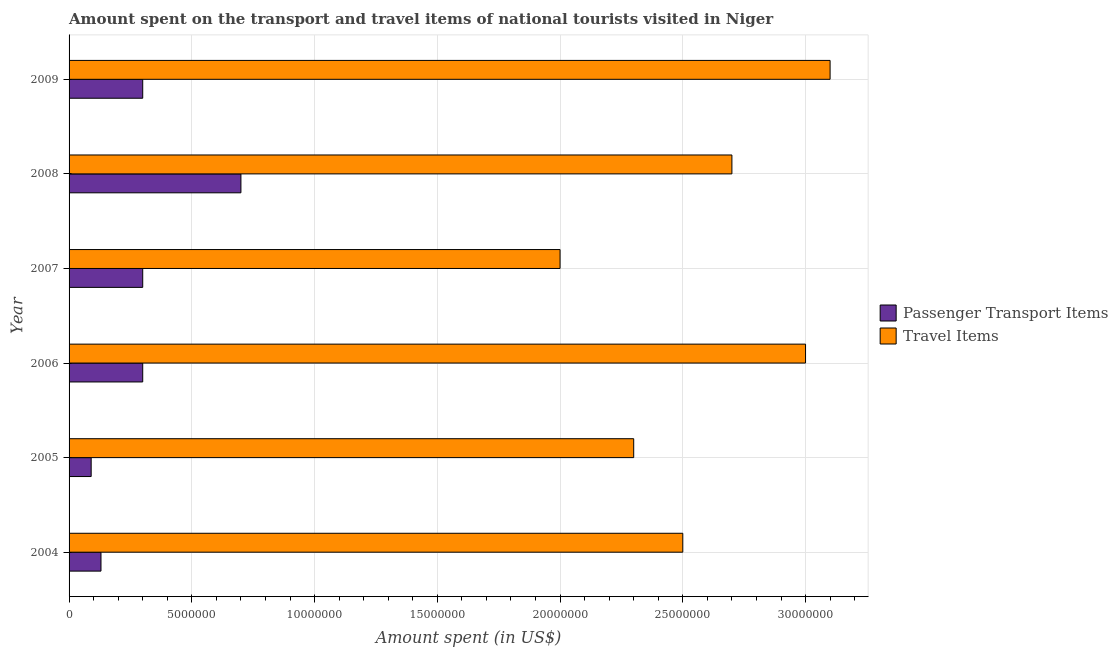How many different coloured bars are there?
Your answer should be compact. 2. How many groups of bars are there?
Provide a succinct answer. 6. Are the number of bars per tick equal to the number of legend labels?
Provide a short and direct response. Yes. What is the amount spent on passenger transport items in 2004?
Provide a succinct answer. 1.30e+06. Across all years, what is the maximum amount spent in travel items?
Make the answer very short. 3.10e+07. Across all years, what is the minimum amount spent in travel items?
Give a very brief answer. 2.00e+07. In which year was the amount spent on passenger transport items minimum?
Provide a succinct answer. 2005. What is the total amount spent in travel items in the graph?
Offer a very short reply. 1.56e+08. What is the difference between the amount spent on passenger transport items in 2004 and that in 2008?
Provide a succinct answer. -5.70e+06. What is the difference between the amount spent on passenger transport items in 2004 and the amount spent in travel items in 2006?
Give a very brief answer. -2.87e+07. What is the average amount spent on passenger transport items per year?
Provide a succinct answer. 3.03e+06. In the year 2006, what is the difference between the amount spent on passenger transport items and amount spent in travel items?
Your response must be concise. -2.70e+07. In how many years, is the amount spent on passenger transport items greater than 17000000 US$?
Offer a terse response. 0. What is the difference between the highest and the lowest amount spent in travel items?
Keep it short and to the point. 1.10e+07. What does the 1st bar from the top in 2004 represents?
Give a very brief answer. Travel Items. What does the 2nd bar from the bottom in 2006 represents?
Your response must be concise. Travel Items. How many bars are there?
Offer a very short reply. 12. What is the difference between two consecutive major ticks on the X-axis?
Give a very brief answer. 5.00e+06. Does the graph contain any zero values?
Make the answer very short. No. How many legend labels are there?
Your answer should be compact. 2. How are the legend labels stacked?
Your answer should be very brief. Vertical. What is the title of the graph?
Provide a short and direct response. Amount spent on the transport and travel items of national tourists visited in Niger. Does "% of gross capital formation" appear as one of the legend labels in the graph?
Keep it short and to the point. No. What is the label or title of the X-axis?
Ensure brevity in your answer.  Amount spent (in US$). What is the Amount spent (in US$) in Passenger Transport Items in 2004?
Provide a succinct answer. 1.30e+06. What is the Amount spent (in US$) of Travel Items in 2004?
Provide a short and direct response. 2.50e+07. What is the Amount spent (in US$) in Travel Items in 2005?
Keep it short and to the point. 2.30e+07. What is the Amount spent (in US$) of Travel Items in 2006?
Provide a short and direct response. 3.00e+07. What is the Amount spent (in US$) in Passenger Transport Items in 2007?
Make the answer very short. 3.00e+06. What is the Amount spent (in US$) in Travel Items in 2008?
Provide a short and direct response. 2.70e+07. What is the Amount spent (in US$) in Travel Items in 2009?
Give a very brief answer. 3.10e+07. Across all years, what is the maximum Amount spent (in US$) of Travel Items?
Provide a short and direct response. 3.10e+07. Across all years, what is the minimum Amount spent (in US$) of Passenger Transport Items?
Your response must be concise. 9.00e+05. What is the total Amount spent (in US$) in Passenger Transport Items in the graph?
Offer a terse response. 1.82e+07. What is the total Amount spent (in US$) in Travel Items in the graph?
Give a very brief answer. 1.56e+08. What is the difference between the Amount spent (in US$) in Passenger Transport Items in 2004 and that in 2005?
Provide a succinct answer. 4.00e+05. What is the difference between the Amount spent (in US$) in Passenger Transport Items in 2004 and that in 2006?
Give a very brief answer. -1.70e+06. What is the difference between the Amount spent (in US$) of Travel Items in 2004 and that in 2006?
Keep it short and to the point. -5.00e+06. What is the difference between the Amount spent (in US$) of Passenger Transport Items in 2004 and that in 2007?
Keep it short and to the point. -1.70e+06. What is the difference between the Amount spent (in US$) of Travel Items in 2004 and that in 2007?
Provide a succinct answer. 5.00e+06. What is the difference between the Amount spent (in US$) in Passenger Transport Items in 2004 and that in 2008?
Offer a terse response. -5.70e+06. What is the difference between the Amount spent (in US$) in Passenger Transport Items in 2004 and that in 2009?
Provide a succinct answer. -1.70e+06. What is the difference between the Amount spent (in US$) in Travel Items in 2004 and that in 2009?
Keep it short and to the point. -6.00e+06. What is the difference between the Amount spent (in US$) in Passenger Transport Items in 2005 and that in 2006?
Your response must be concise. -2.10e+06. What is the difference between the Amount spent (in US$) in Travel Items in 2005 and that in 2006?
Your response must be concise. -7.00e+06. What is the difference between the Amount spent (in US$) of Passenger Transport Items in 2005 and that in 2007?
Give a very brief answer. -2.10e+06. What is the difference between the Amount spent (in US$) of Passenger Transport Items in 2005 and that in 2008?
Give a very brief answer. -6.10e+06. What is the difference between the Amount spent (in US$) in Passenger Transport Items in 2005 and that in 2009?
Keep it short and to the point. -2.10e+06. What is the difference between the Amount spent (in US$) in Travel Items in 2005 and that in 2009?
Provide a short and direct response. -8.00e+06. What is the difference between the Amount spent (in US$) in Passenger Transport Items in 2006 and that in 2007?
Offer a very short reply. 0. What is the difference between the Amount spent (in US$) in Passenger Transport Items in 2006 and that in 2009?
Your response must be concise. 0. What is the difference between the Amount spent (in US$) in Travel Items in 2007 and that in 2008?
Provide a short and direct response. -7.00e+06. What is the difference between the Amount spent (in US$) in Travel Items in 2007 and that in 2009?
Provide a succinct answer. -1.10e+07. What is the difference between the Amount spent (in US$) of Travel Items in 2008 and that in 2009?
Your answer should be compact. -4.00e+06. What is the difference between the Amount spent (in US$) in Passenger Transport Items in 2004 and the Amount spent (in US$) in Travel Items in 2005?
Give a very brief answer. -2.17e+07. What is the difference between the Amount spent (in US$) of Passenger Transport Items in 2004 and the Amount spent (in US$) of Travel Items in 2006?
Make the answer very short. -2.87e+07. What is the difference between the Amount spent (in US$) in Passenger Transport Items in 2004 and the Amount spent (in US$) in Travel Items in 2007?
Give a very brief answer. -1.87e+07. What is the difference between the Amount spent (in US$) in Passenger Transport Items in 2004 and the Amount spent (in US$) in Travel Items in 2008?
Provide a short and direct response. -2.57e+07. What is the difference between the Amount spent (in US$) of Passenger Transport Items in 2004 and the Amount spent (in US$) of Travel Items in 2009?
Offer a terse response. -2.97e+07. What is the difference between the Amount spent (in US$) of Passenger Transport Items in 2005 and the Amount spent (in US$) of Travel Items in 2006?
Offer a terse response. -2.91e+07. What is the difference between the Amount spent (in US$) in Passenger Transport Items in 2005 and the Amount spent (in US$) in Travel Items in 2007?
Offer a terse response. -1.91e+07. What is the difference between the Amount spent (in US$) in Passenger Transport Items in 2005 and the Amount spent (in US$) in Travel Items in 2008?
Your answer should be compact. -2.61e+07. What is the difference between the Amount spent (in US$) in Passenger Transport Items in 2005 and the Amount spent (in US$) in Travel Items in 2009?
Keep it short and to the point. -3.01e+07. What is the difference between the Amount spent (in US$) in Passenger Transport Items in 2006 and the Amount spent (in US$) in Travel Items in 2007?
Make the answer very short. -1.70e+07. What is the difference between the Amount spent (in US$) of Passenger Transport Items in 2006 and the Amount spent (in US$) of Travel Items in 2008?
Give a very brief answer. -2.40e+07. What is the difference between the Amount spent (in US$) in Passenger Transport Items in 2006 and the Amount spent (in US$) in Travel Items in 2009?
Keep it short and to the point. -2.80e+07. What is the difference between the Amount spent (in US$) in Passenger Transport Items in 2007 and the Amount spent (in US$) in Travel Items in 2008?
Keep it short and to the point. -2.40e+07. What is the difference between the Amount spent (in US$) in Passenger Transport Items in 2007 and the Amount spent (in US$) in Travel Items in 2009?
Ensure brevity in your answer.  -2.80e+07. What is the difference between the Amount spent (in US$) of Passenger Transport Items in 2008 and the Amount spent (in US$) of Travel Items in 2009?
Provide a short and direct response. -2.40e+07. What is the average Amount spent (in US$) of Passenger Transport Items per year?
Make the answer very short. 3.03e+06. What is the average Amount spent (in US$) of Travel Items per year?
Ensure brevity in your answer.  2.60e+07. In the year 2004, what is the difference between the Amount spent (in US$) of Passenger Transport Items and Amount spent (in US$) of Travel Items?
Give a very brief answer. -2.37e+07. In the year 2005, what is the difference between the Amount spent (in US$) of Passenger Transport Items and Amount spent (in US$) of Travel Items?
Make the answer very short. -2.21e+07. In the year 2006, what is the difference between the Amount spent (in US$) in Passenger Transport Items and Amount spent (in US$) in Travel Items?
Provide a succinct answer. -2.70e+07. In the year 2007, what is the difference between the Amount spent (in US$) of Passenger Transport Items and Amount spent (in US$) of Travel Items?
Ensure brevity in your answer.  -1.70e+07. In the year 2008, what is the difference between the Amount spent (in US$) in Passenger Transport Items and Amount spent (in US$) in Travel Items?
Make the answer very short. -2.00e+07. In the year 2009, what is the difference between the Amount spent (in US$) in Passenger Transport Items and Amount spent (in US$) in Travel Items?
Ensure brevity in your answer.  -2.80e+07. What is the ratio of the Amount spent (in US$) in Passenger Transport Items in 2004 to that in 2005?
Your answer should be compact. 1.44. What is the ratio of the Amount spent (in US$) in Travel Items in 2004 to that in 2005?
Provide a succinct answer. 1.09. What is the ratio of the Amount spent (in US$) in Passenger Transport Items in 2004 to that in 2006?
Your answer should be compact. 0.43. What is the ratio of the Amount spent (in US$) of Passenger Transport Items in 2004 to that in 2007?
Your answer should be very brief. 0.43. What is the ratio of the Amount spent (in US$) in Travel Items in 2004 to that in 2007?
Offer a very short reply. 1.25. What is the ratio of the Amount spent (in US$) of Passenger Transport Items in 2004 to that in 2008?
Provide a succinct answer. 0.19. What is the ratio of the Amount spent (in US$) in Travel Items in 2004 to that in 2008?
Your answer should be compact. 0.93. What is the ratio of the Amount spent (in US$) of Passenger Transport Items in 2004 to that in 2009?
Give a very brief answer. 0.43. What is the ratio of the Amount spent (in US$) of Travel Items in 2004 to that in 2009?
Offer a very short reply. 0.81. What is the ratio of the Amount spent (in US$) of Travel Items in 2005 to that in 2006?
Offer a terse response. 0.77. What is the ratio of the Amount spent (in US$) of Passenger Transport Items in 2005 to that in 2007?
Give a very brief answer. 0.3. What is the ratio of the Amount spent (in US$) of Travel Items in 2005 to that in 2007?
Your response must be concise. 1.15. What is the ratio of the Amount spent (in US$) in Passenger Transport Items in 2005 to that in 2008?
Give a very brief answer. 0.13. What is the ratio of the Amount spent (in US$) of Travel Items in 2005 to that in 2008?
Ensure brevity in your answer.  0.85. What is the ratio of the Amount spent (in US$) in Travel Items in 2005 to that in 2009?
Give a very brief answer. 0.74. What is the ratio of the Amount spent (in US$) of Passenger Transport Items in 2006 to that in 2007?
Keep it short and to the point. 1. What is the ratio of the Amount spent (in US$) of Passenger Transport Items in 2006 to that in 2008?
Your answer should be very brief. 0.43. What is the ratio of the Amount spent (in US$) in Passenger Transport Items in 2007 to that in 2008?
Your response must be concise. 0.43. What is the ratio of the Amount spent (in US$) in Travel Items in 2007 to that in 2008?
Give a very brief answer. 0.74. What is the ratio of the Amount spent (in US$) in Passenger Transport Items in 2007 to that in 2009?
Offer a very short reply. 1. What is the ratio of the Amount spent (in US$) in Travel Items in 2007 to that in 2009?
Your answer should be compact. 0.65. What is the ratio of the Amount spent (in US$) in Passenger Transport Items in 2008 to that in 2009?
Give a very brief answer. 2.33. What is the ratio of the Amount spent (in US$) of Travel Items in 2008 to that in 2009?
Offer a very short reply. 0.87. What is the difference between the highest and the second highest Amount spent (in US$) in Passenger Transport Items?
Your answer should be compact. 4.00e+06. What is the difference between the highest and the second highest Amount spent (in US$) in Travel Items?
Provide a short and direct response. 1.00e+06. What is the difference between the highest and the lowest Amount spent (in US$) in Passenger Transport Items?
Give a very brief answer. 6.10e+06. What is the difference between the highest and the lowest Amount spent (in US$) in Travel Items?
Provide a succinct answer. 1.10e+07. 